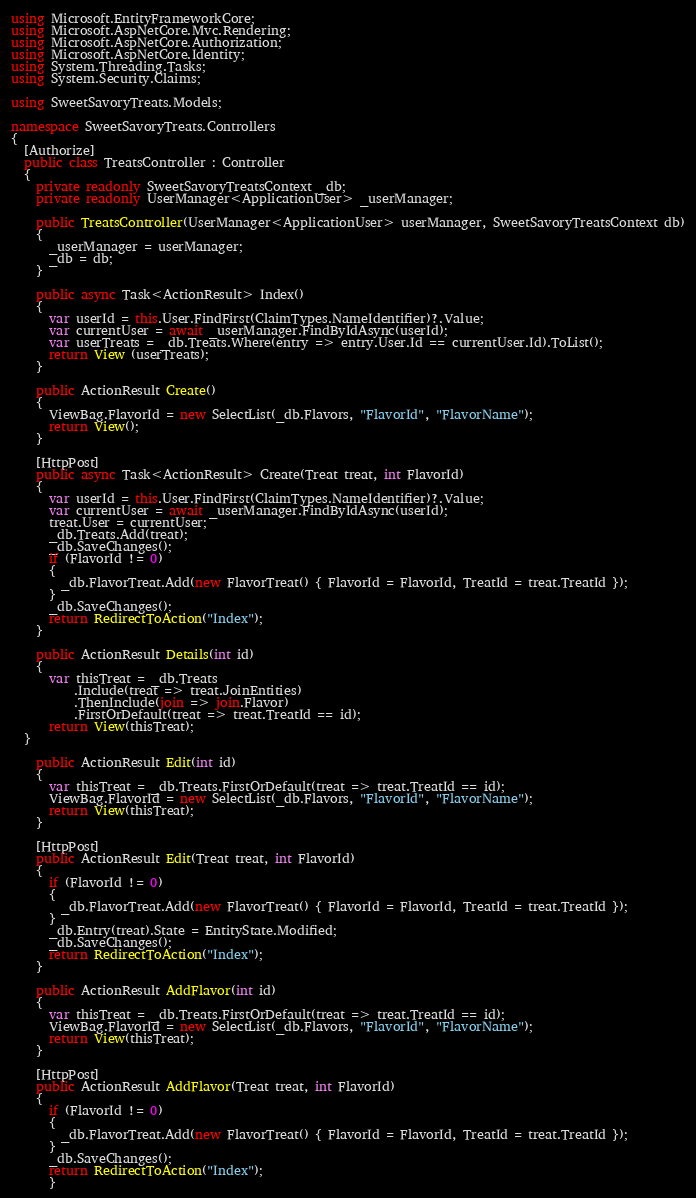Convert code to text. <code><loc_0><loc_0><loc_500><loc_500><_C#_>using Microsoft.EntityFrameworkCore;
using Microsoft.AspNetCore.Mvc.Rendering;
using Microsoft.AspNetCore.Authorization;
using Microsoft.AspNetCore.Identity;
using System.Threading.Tasks;
using System.Security.Claims;

using SweetSavoryTreats.Models;

namespace SweetSavoryTreats.Controllers
{
  [Authorize]
  public class TreatsController : Controller
  {
    private readonly SweetSavoryTreatsContext _db;
    private readonly UserManager<ApplicationUser> _userManager;

    public TreatsController(UserManager<ApplicationUser> userManager, SweetSavoryTreatsContext db)
    {
      _userManager = userManager;
      _db = db;
    }

    public async Task<ActionResult> Index()
    {
      var userId = this.User.FindFirst(ClaimTypes.NameIdentifier)?.Value;
      var currentUser = await _userManager.FindByIdAsync(userId); 
      var userTreats = _db.Treats.Where(entry => entry.User.Id == currentUser.Id).ToList();
      return View (userTreats);
    }

    public ActionResult Create()
    {
      ViewBag.FlavorId = new SelectList(_db.Flavors, "FlavorId", "FlavorName");
      return View();
    }

    [HttpPost]
    public async Task<ActionResult> Create(Treat treat, int FlavorId)
    {
      var userId = this.User.FindFirst(ClaimTypes.NameIdentifier)?.Value;
      var currentUser = await _userManager.FindByIdAsync(userId);
      treat.User = currentUser;
      _db.Treats.Add(treat);
      _db.SaveChanges();
      if (FlavorId != 0)
      {
        _db.FlavorTreat.Add(new FlavorTreat() { FlavorId = FlavorId, TreatId = treat.TreatId });
      }
      _db.SaveChanges();
      return RedirectToAction("Index");
    }

    public ActionResult Details(int id)
    {
      var thisTreat = _db.Treats
          .Include(treat => treat.JoinEntities)
          .ThenInclude(join => join.Flavor)
          .FirstOrDefault(treat => treat.TreatId == id);
      return View(thisTreat);
  }

    public ActionResult Edit(int id)
    {
      var thisTreat = _db.Treats.FirstOrDefault(treat => treat.TreatId == id);
      ViewBag.FlavorId = new SelectList(_db.Flavors, "FlavorId", "FlavorName");
      return View(thisTreat);
    }

    [HttpPost]
    public ActionResult Edit(Treat treat, int FlavorId)
    {
      if (FlavorId != 0)
      {
        _db.FlavorTreat.Add(new FlavorTreat() { FlavorId = FlavorId, TreatId = treat.TreatId });
      }
      _db.Entry(treat).State = EntityState.Modified;
      _db.SaveChanges();
      return RedirectToAction("Index");
    }

    public ActionResult AddFlavor(int id)
    {
      var thisTreat = _db.Treats.FirstOrDefault(treat => treat.TreatId == id);
      ViewBag.FlavorId = new SelectList(_db.Flavors, "FlavorId", "FlavorName");
      return View(thisTreat);
    }

    [HttpPost]
    public ActionResult AddFlavor(Treat treat, int FlavorId)
    {
      if (FlavorId != 0)
      {
        _db.FlavorTreat.Add(new FlavorTreat() { FlavorId = FlavorId, TreatId = treat.TreatId });
      }
      _db.SaveChanges();
      return RedirectToAction("Index");
      }
</code> 